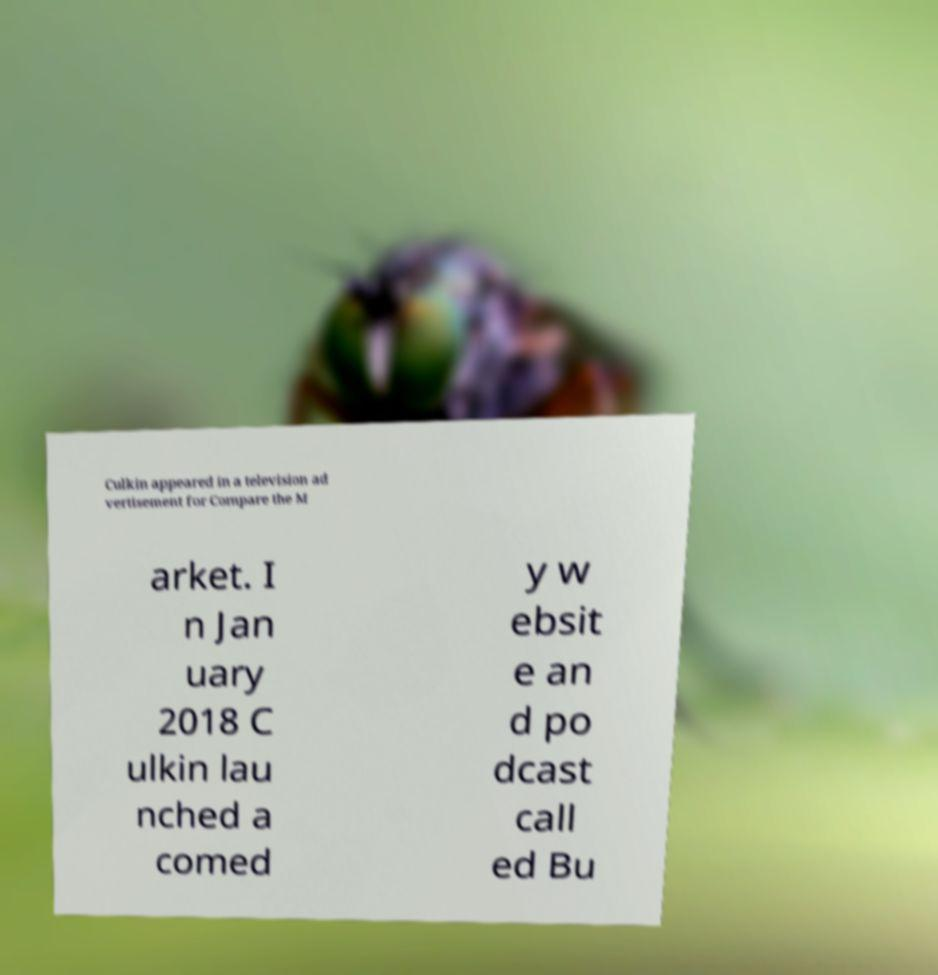What messages or text are displayed in this image? I need them in a readable, typed format. Culkin appeared in a television ad vertisement for Compare the M arket. I n Jan uary 2018 C ulkin lau nched a comed y w ebsit e an d po dcast call ed Bu 